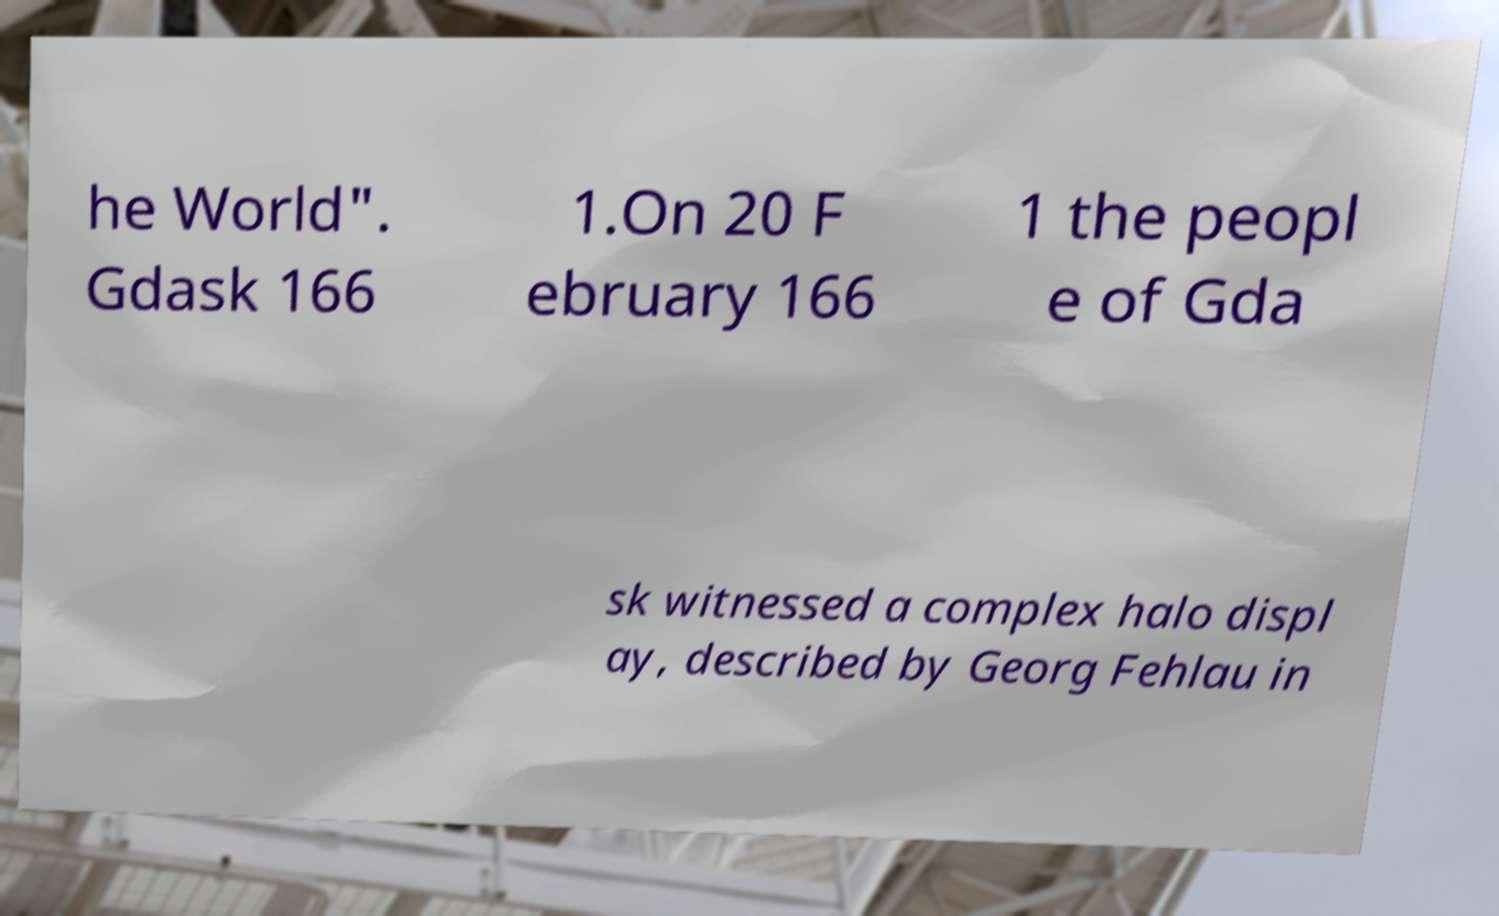Could you extract and type out the text from this image? he World". Gdask 166 1.On 20 F ebruary 166 1 the peopl e of Gda sk witnessed a complex halo displ ay, described by Georg Fehlau in 